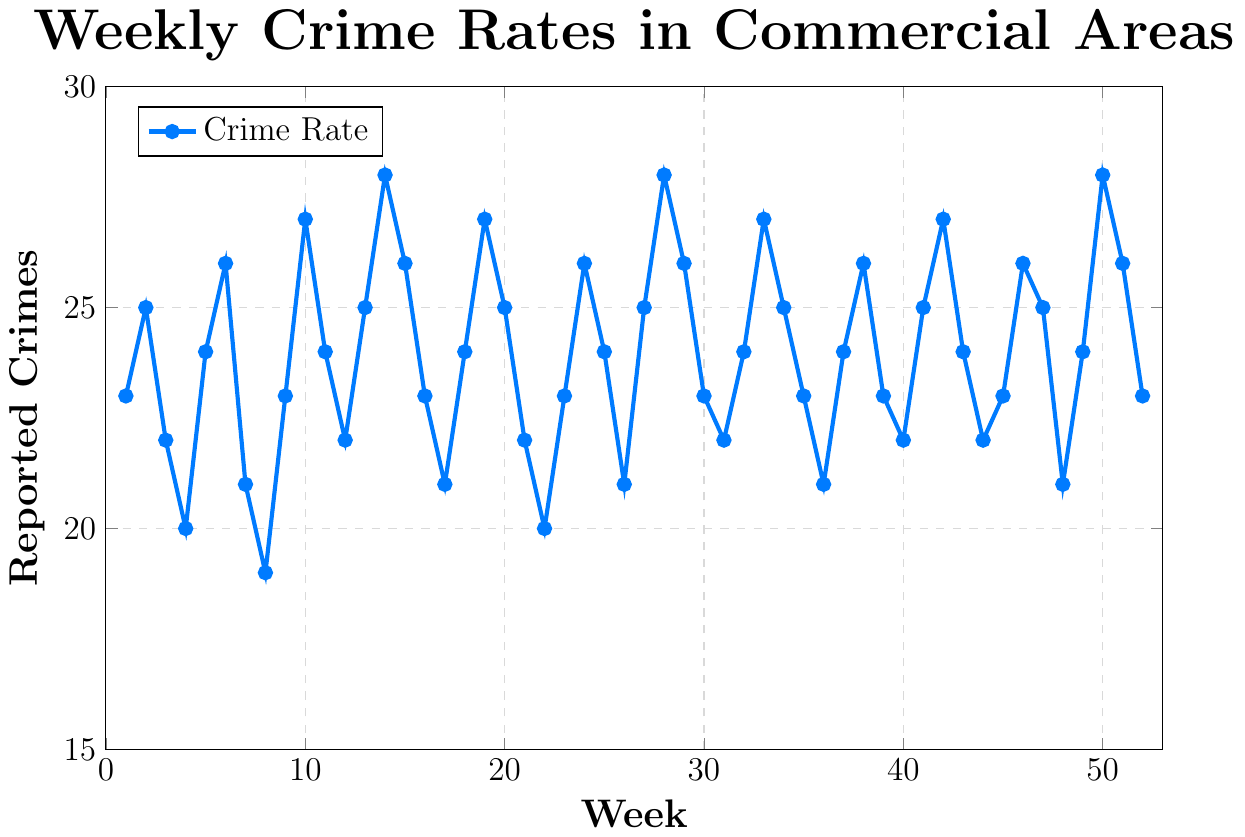What's the highest number of reported crimes in a single week? Look for the peak value on the y-axis. The highest point on the blue line is at week 14 and 50, which both have a value of 28.
Answer: 28 What's the lowest number of reported crimes in a single week? Look for the lowest point on the y-axis. The lowest point on the blue line is at week 8, which has a value of 19.
Answer: 19 During which weeks did the number of reported crimes peak? Identify the weeks where the highest values on the y-axis occur. The peaks at 28 reported crimes are in weeks 14, 28, and 50.
Answer: 14, 28, 50 What is the average number of reported crimes over the 52 weeks? Sum all the values and divide by the number of weeks. (23+25+22+20+24+26+21+19+23+27+24+22+25+28+26+23+21+24+27+25+22+20+23+26+24+21+25+28+26+23+22+24+27+25+23+21+24+26+23+22+25+27+24+22+23+26+25+21+24+28+26+23)/52 = 24.21
Answer: 24.21 How many times did the number of reported crimes drop to 20 or below? Identify the weeks where the reported number of crimes is 20 or less. These are weeks 4, 8, and 22.
Answer: 3 During which week(s) did the number of reported crimes drop after reaching a peak of 27? Look for the weeks before and after the peaks of 27. Week 10 drops to 24 (week 11), week 19 drops to 25 (week 20), and week 42 drops to 24 (week 43).
Answer: 10, 19, 42 What is the trend in crime rate from week 1 to week 52? Look at the overall shape of the blue line from the beginning to the end. The trend fluctuates but stays within a similar range, ending at the same value it started with (23).
Answer: Fluctuates, stable Compare the number of reported crimes in week 10 and week 11. Which is higher? Week 10 has 27 reported crimes, and week 11 has 24 reported crimes.
Answer: Week 10 